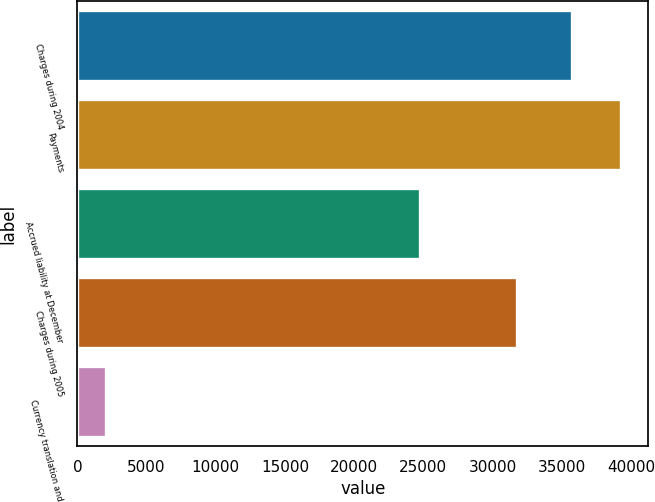<chart> <loc_0><loc_0><loc_500><loc_500><bar_chart><fcel>Charges during 2004<fcel>Payments<fcel>Accrued liability at December<fcel>Charges during 2005<fcel>Currency translation and<nl><fcel>35781<fcel>39280.4<fcel>24773<fcel>31771.8<fcel>2047<nl></chart> 